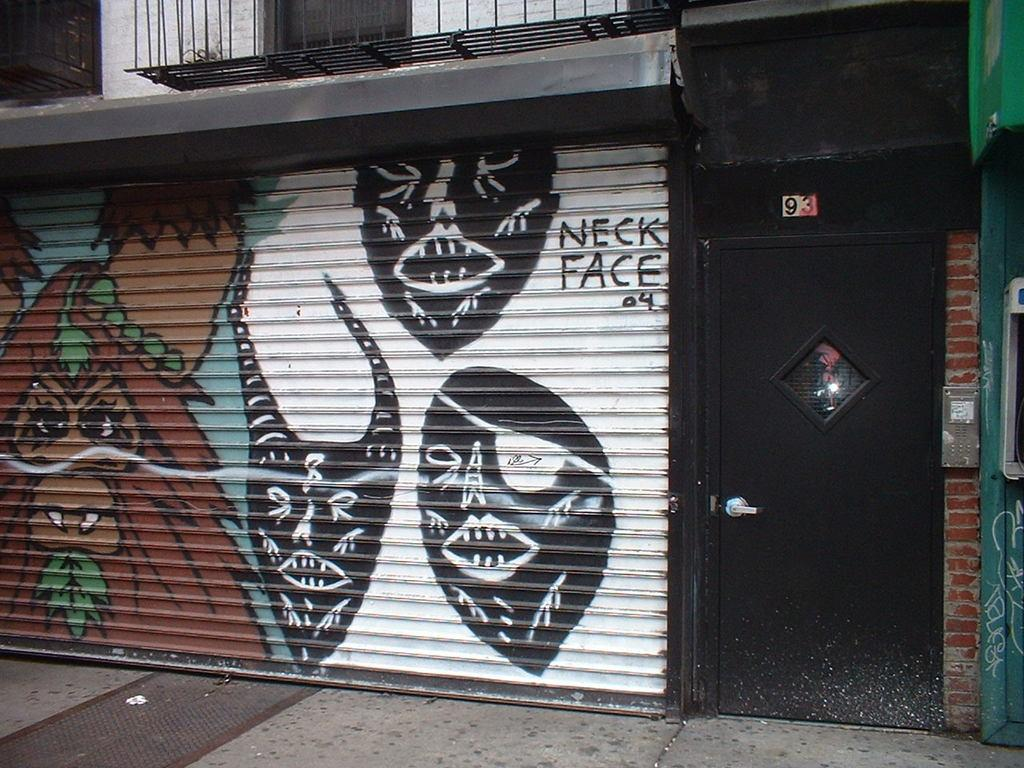What type of gate can be seen in the image? There is a black colored gate in the image. What other feature is present in the image? There is a rolling shutter in the image. What colors can be seen on the rolling shutter? The rolling shutter is black, brown, white, green, and blue in color. What type of structure is visible in the image? There is a building in the image. How many legs does the cobweb have in the image? There is no cobweb present in the image. Where is the middle of the image located? The concept of a "middle" of the image is abstract and cannot be definitively determined from the provided facts. 